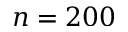Convert formula to latex. <formula><loc_0><loc_0><loc_500><loc_500>n = 2 0 0</formula> 